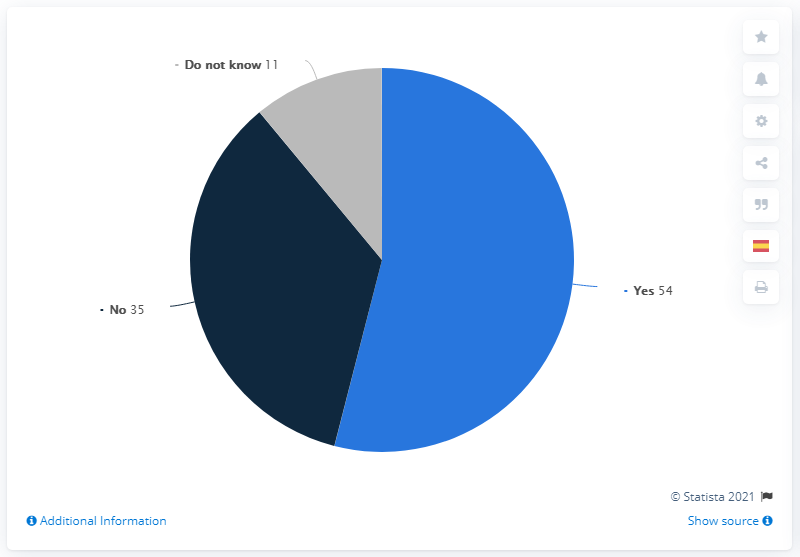Give some essential details in this illustration. The majority of the Mexican population believed that the coronavirus would come, according to a recent survey. Nineteen people in Mexico believed that the COVID-19 pandemic would occur, while the remaining did not think so. According to a survey conducted in Mexico in early 2020, a majority of respondents, 54%, believed that the coronavirus would eventually reach Mexico. 